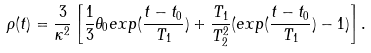<formula> <loc_0><loc_0><loc_500><loc_500>\rho ( t ) = \frac { 3 } { \kappa ^ { 2 } } \left [ \frac { 1 } { 3 } \theta _ { 0 } e x p ( \frac { t - t _ { 0 } } { T _ { 1 } } ) + \frac { T _ { 1 } } { T ^ { 2 } _ { 2 } } ( e x p ( \frac { t - t _ { 0 } } { T _ { 1 } } ) - 1 ) \right ] .</formula> 